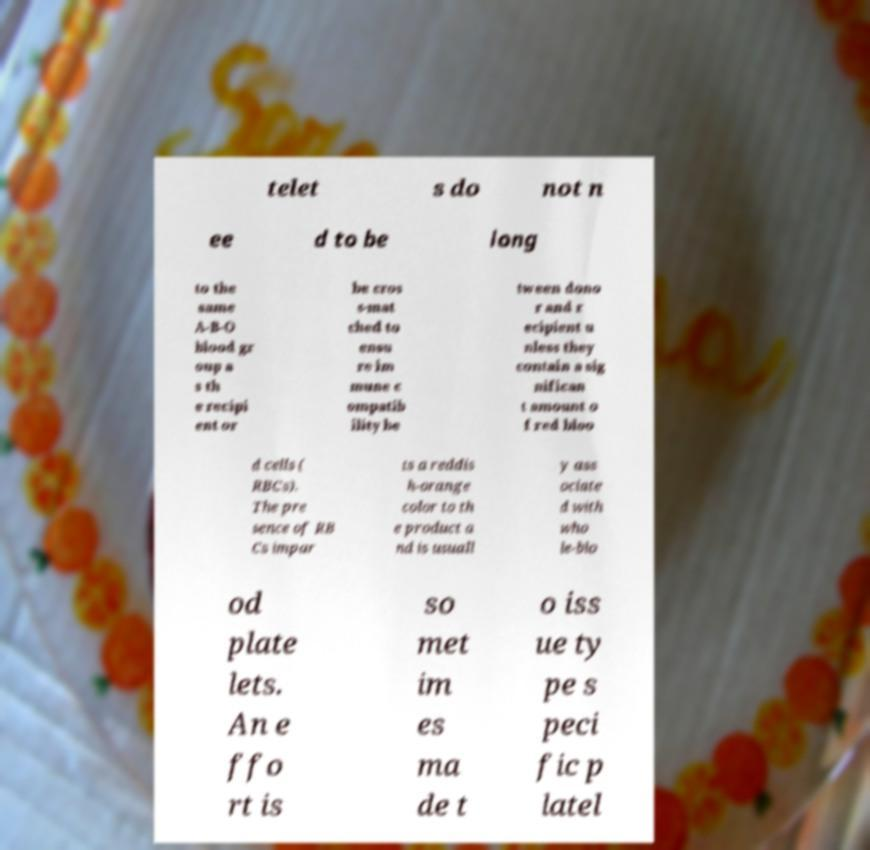Please identify and transcribe the text found in this image. telet s do not n ee d to be long to the same A-B-O blood gr oup a s th e recipi ent or be cros s-mat ched to ensu re im mune c ompatib ility be tween dono r and r ecipient u nless they contain a sig nifican t amount o f red bloo d cells ( RBCs). The pre sence of RB Cs impar ts a reddis h-orange color to th e product a nd is usuall y ass ociate d with who le-blo od plate lets. An e ffo rt is so met im es ma de t o iss ue ty pe s peci fic p latel 